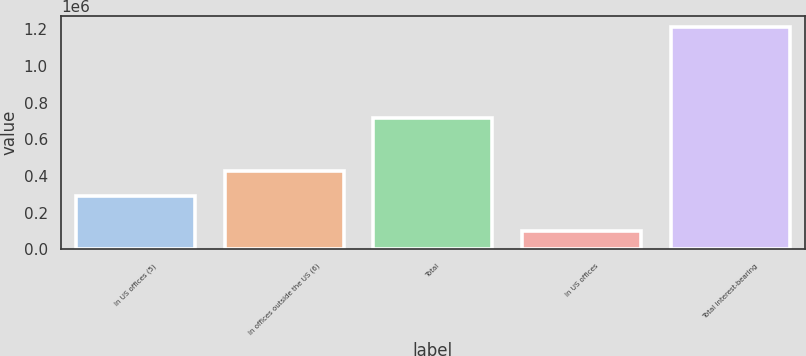Convert chart to OTSL. <chart><loc_0><loc_0><loc_500><loc_500><bar_chart><fcel>In US offices (5)<fcel>In offices outside the US (6)<fcel>Total<fcel>In US offices<fcel>Total interest-bearing<nl><fcel>288817<fcel>429608<fcel>718425<fcel>100472<fcel>1.2126e+06<nl></chart> 